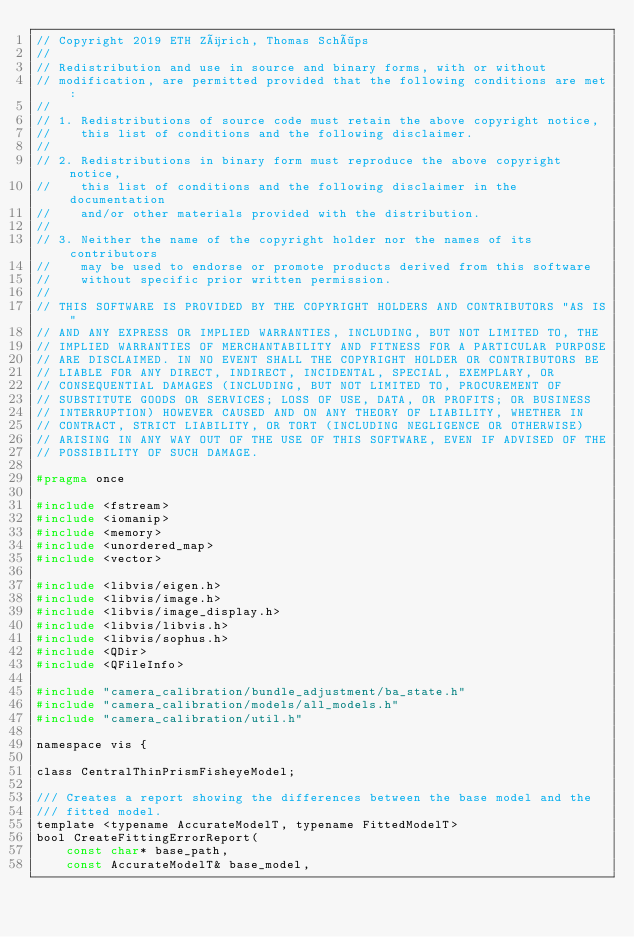Convert code to text. <code><loc_0><loc_0><loc_500><loc_500><_C_>// Copyright 2019 ETH Zürich, Thomas Schöps
//
// Redistribution and use in source and binary forms, with or without
// modification, are permitted provided that the following conditions are met:
//
// 1. Redistributions of source code must retain the above copyright notice,
//    this list of conditions and the following disclaimer.
//
// 2. Redistributions in binary form must reproduce the above copyright notice,
//    this list of conditions and the following disclaimer in the documentation
//    and/or other materials provided with the distribution.
//
// 3. Neither the name of the copyright holder nor the names of its contributors
//    may be used to endorse or promote products derived from this software
//    without specific prior written permission.
//
// THIS SOFTWARE IS PROVIDED BY THE COPYRIGHT HOLDERS AND CONTRIBUTORS "AS IS"
// AND ANY EXPRESS OR IMPLIED WARRANTIES, INCLUDING, BUT NOT LIMITED TO, THE
// IMPLIED WARRANTIES OF MERCHANTABILITY AND FITNESS FOR A PARTICULAR PURPOSE
// ARE DISCLAIMED. IN NO EVENT SHALL THE COPYRIGHT HOLDER OR CONTRIBUTORS BE
// LIABLE FOR ANY DIRECT, INDIRECT, INCIDENTAL, SPECIAL, EXEMPLARY, OR
// CONSEQUENTIAL DAMAGES (INCLUDING, BUT NOT LIMITED TO, PROCUREMENT OF
// SUBSTITUTE GOODS OR SERVICES; LOSS OF USE, DATA, OR PROFITS; OR BUSINESS
// INTERRUPTION) HOWEVER CAUSED AND ON ANY THEORY OF LIABILITY, WHETHER IN
// CONTRACT, STRICT LIABILITY, OR TORT (INCLUDING NEGLIGENCE OR OTHERWISE)
// ARISING IN ANY WAY OUT OF THE USE OF THIS SOFTWARE, EVEN IF ADVISED OF THE
// POSSIBILITY OF SUCH DAMAGE.

#pragma once

#include <fstream>
#include <iomanip>
#include <memory>
#include <unordered_map>
#include <vector>

#include <libvis/eigen.h>
#include <libvis/image.h>
#include <libvis/image_display.h>
#include <libvis/libvis.h>
#include <libvis/sophus.h>
#include <QDir>
#include <QFileInfo>

#include "camera_calibration/bundle_adjustment/ba_state.h"
#include "camera_calibration/models/all_models.h"
#include "camera_calibration/util.h"

namespace vis {

class CentralThinPrismFisheyeModel;

/// Creates a report showing the differences between the base model and the
/// fitted model.
template <typename AccurateModelT, typename FittedModelT>
bool CreateFittingErrorReport(
    const char* base_path,
    const AccurateModelT& base_model,</code> 